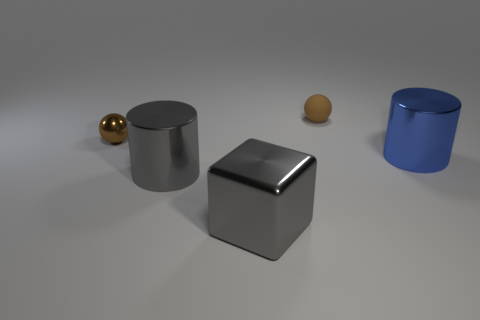What number of other brown balls are the same size as the brown rubber ball?
Make the answer very short. 1. What is the shape of the thing to the right of the brown sphere to the right of the big shiny block?
Provide a short and direct response. Cylinder. There is a small thing right of the metal thing on the left side of the large cylinder left of the blue metallic cylinder; what is its shape?
Keep it short and to the point. Sphere. How many large blue metal objects have the same shape as the tiny rubber thing?
Ensure brevity in your answer.  0. How many large blocks are behind the cylinder that is on the left side of the rubber object?
Your response must be concise. 0. How many matte things are balls or large blocks?
Ensure brevity in your answer.  1. Are there any brown balls made of the same material as the large gray cylinder?
Give a very brief answer. Yes. How many things are either objects that are right of the block or brown objects that are right of the brown metallic thing?
Ensure brevity in your answer.  2. Does the cylinder left of the metallic block have the same color as the big cube?
Make the answer very short. Yes. What number of other objects are the same color as the tiny metallic object?
Give a very brief answer. 1. 